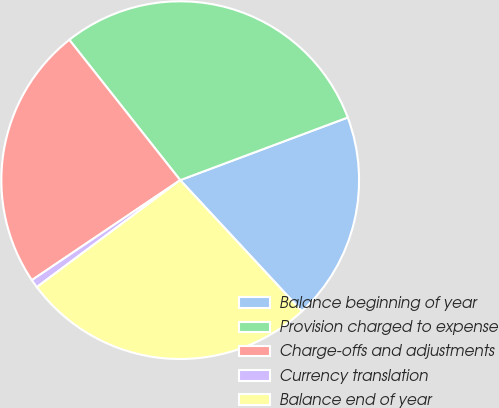<chart> <loc_0><loc_0><loc_500><loc_500><pie_chart><fcel>Balance beginning of year<fcel>Provision charged to expense<fcel>Charge-offs and adjustments<fcel>Currency translation<fcel>Balance end of year<nl><fcel>18.79%<fcel>29.95%<fcel>23.8%<fcel>0.76%<fcel>26.71%<nl></chart> 